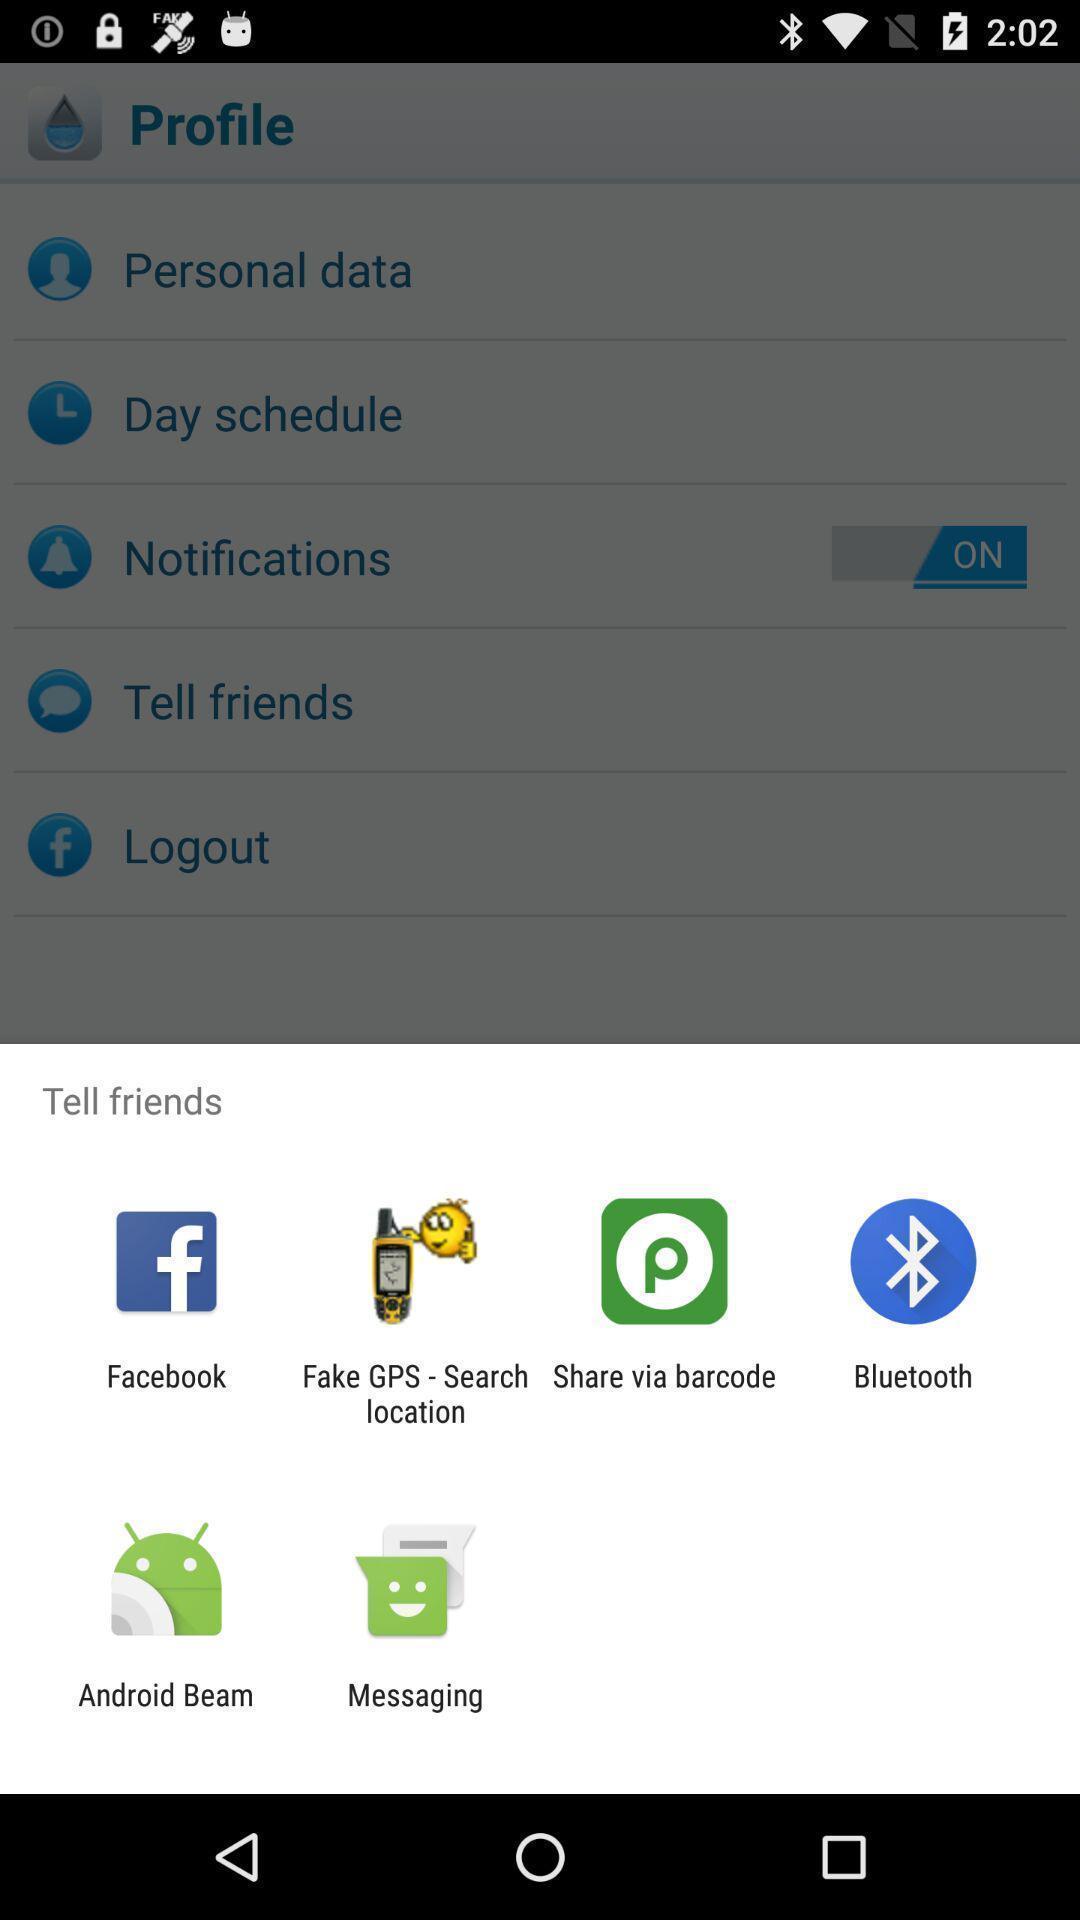Tell me about the visual elements in this screen capture. Pop up showing different apps. 